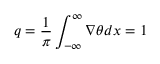<formula> <loc_0><loc_0><loc_500><loc_500>q = \frac { 1 } { \pi } \int _ { - \infty } ^ { \infty } { \nabla \theta d x } = 1</formula> 